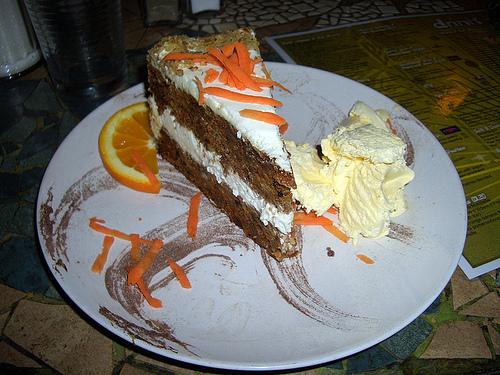What fruit is on the plate?
Give a very brief answer. Orange. Is the plate on a table?
Answer briefly. Yes. What dessert items are on the plate?
Keep it brief. Cake and ice cream. 